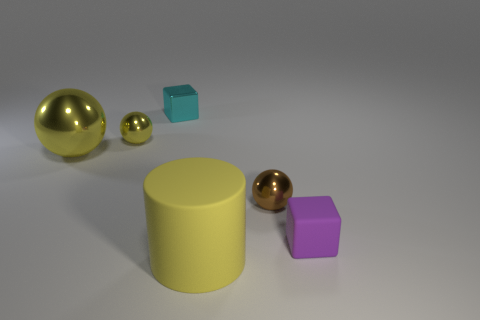Subtract all purple cylinders. How many yellow spheres are left? 2 Subtract all small yellow metal spheres. How many spheres are left? 2 Add 4 green metal blocks. How many objects exist? 10 Subtract all purple spheres. Subtract all cyan cylinders. How many spheres are left? 3 Subtract all cylinders. How many objects are left? 5 Subtract all large red things. Subtract all balls. How many objects are left? 3 Add 4 tiny metallic blocks. How many tiny metallic blocks are left? 5 Add 2 tiny cyan things. How many tiny cyan things exist? 3 Subtract 0 red cylinders. How many objects are left? 6 